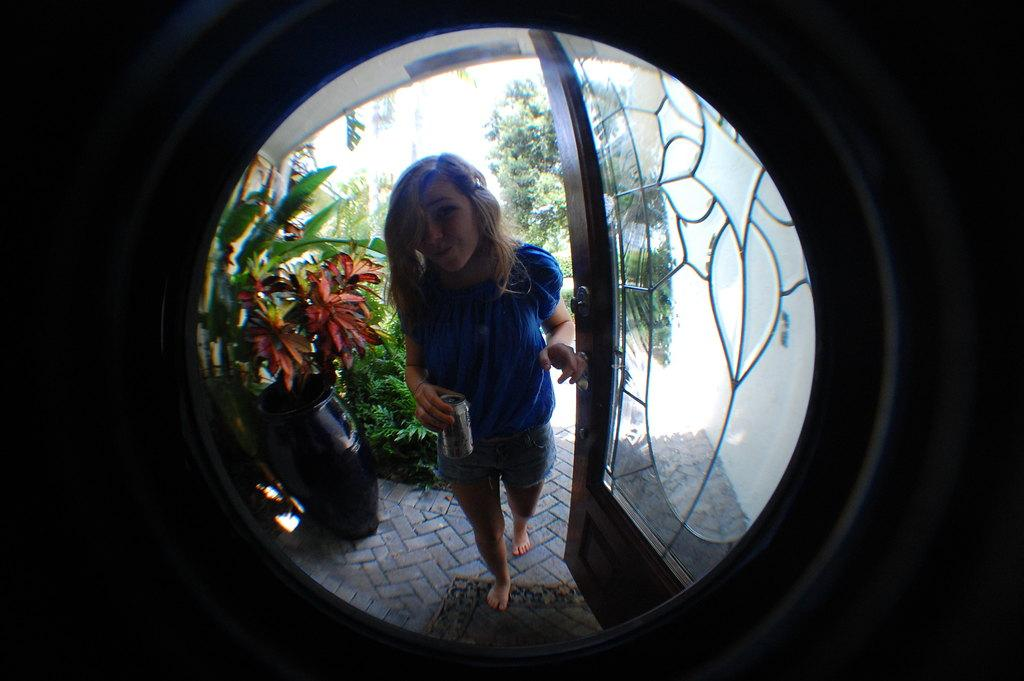What object can be seen in the image that is used for magnification? There is a magnifying glass in the image. What is the lady in the image holding? The lady is holding an object in the image. What architectural feature is present in the image? There is a door in the image. What type of surface is on the ground in the image? There is a ground with a mat in the image. What type of plant is in the image? There is a plant in a pot in the image. What type of vegetation is visible in the background of the image? There are trees in the image. What type of spark can be seen coming from the plant in the image? There is no spark present in the image; it is a plant in a pot. What type of riddle is the lady trying to solve in the image? There is no riddle present in the image; the lady is holding an object. 